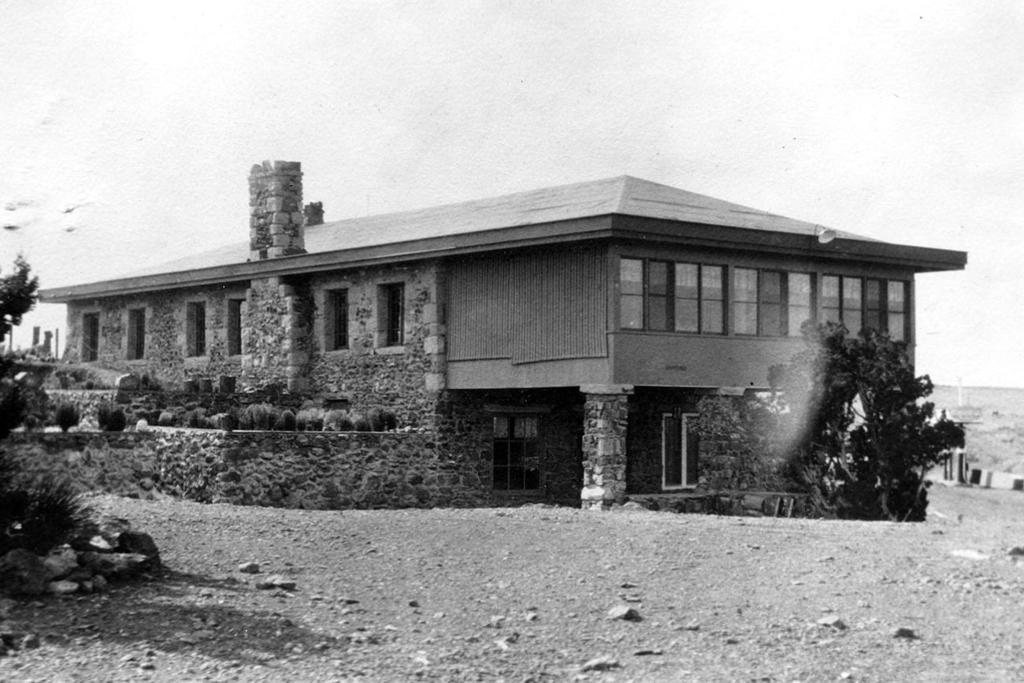What type of structure is present in the image? There is a house in the image. What other natural elements can be seen in the image? There are plants, trees, and rocks visible in the image. What features of the house are shown in the image? There are doors and windows in the image. What can be seen in the background of the image? The sky is visible in the image. What type of songs can be heard playing from the engine in the image? There is no engine or songs present in the image. 